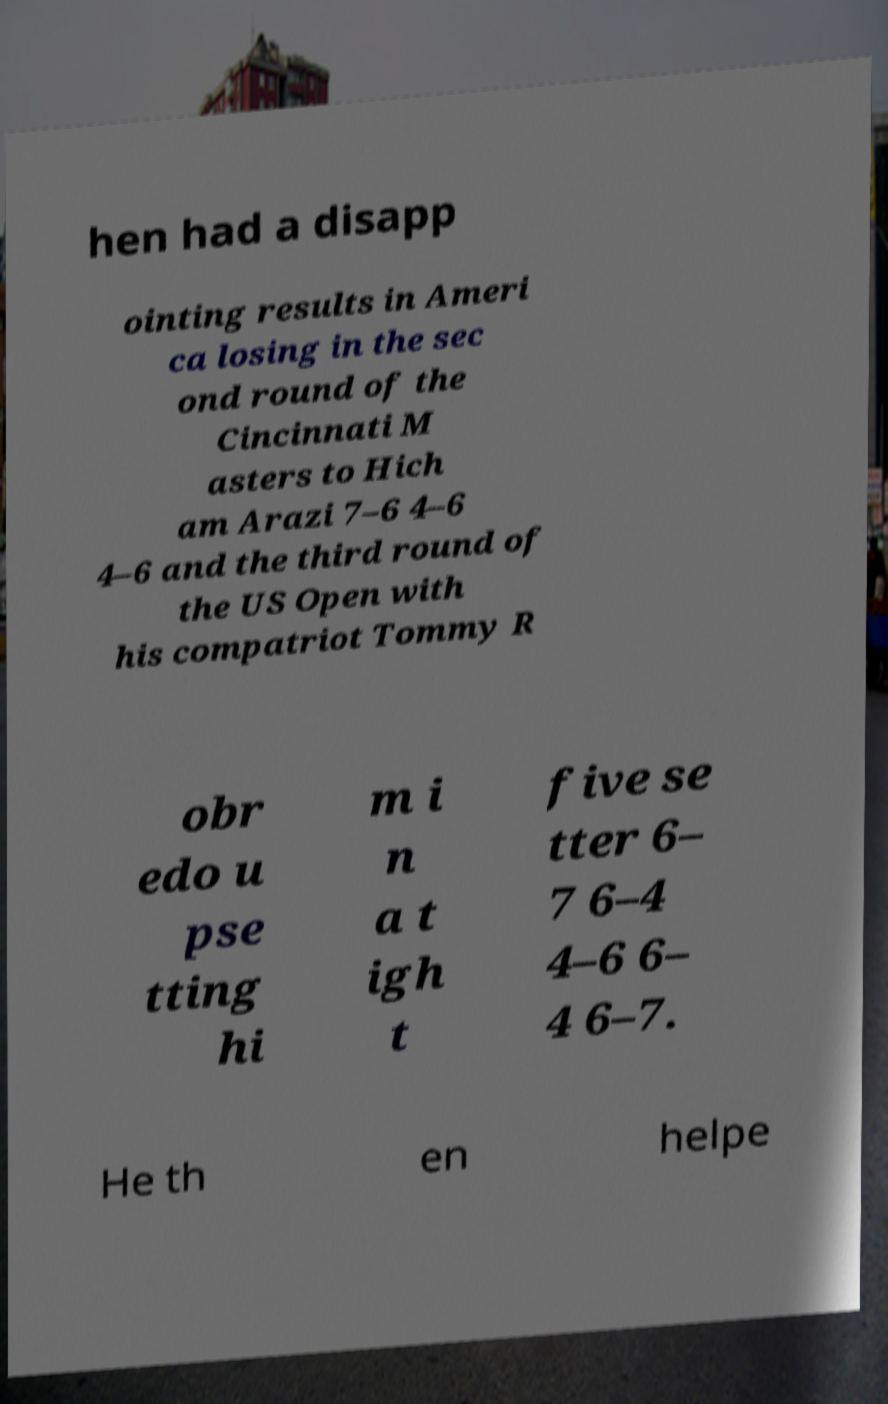Can you read and provide the text displayed in the image?This photo seems to have some interesting text. Can you extract and type it out for me? hen had a disapp ointing results in Ameri ca losing in the sec ond round of the Cincinnati M asters to Hich am Arazi 7–6 4–6 4–6 and the third round of the US Open with his compatriot Tommy R obr edo u pse tting hi m i n a t igh t five se tter 6– 7 6–4 4–6 6– 4 6–7. He th en helpe 